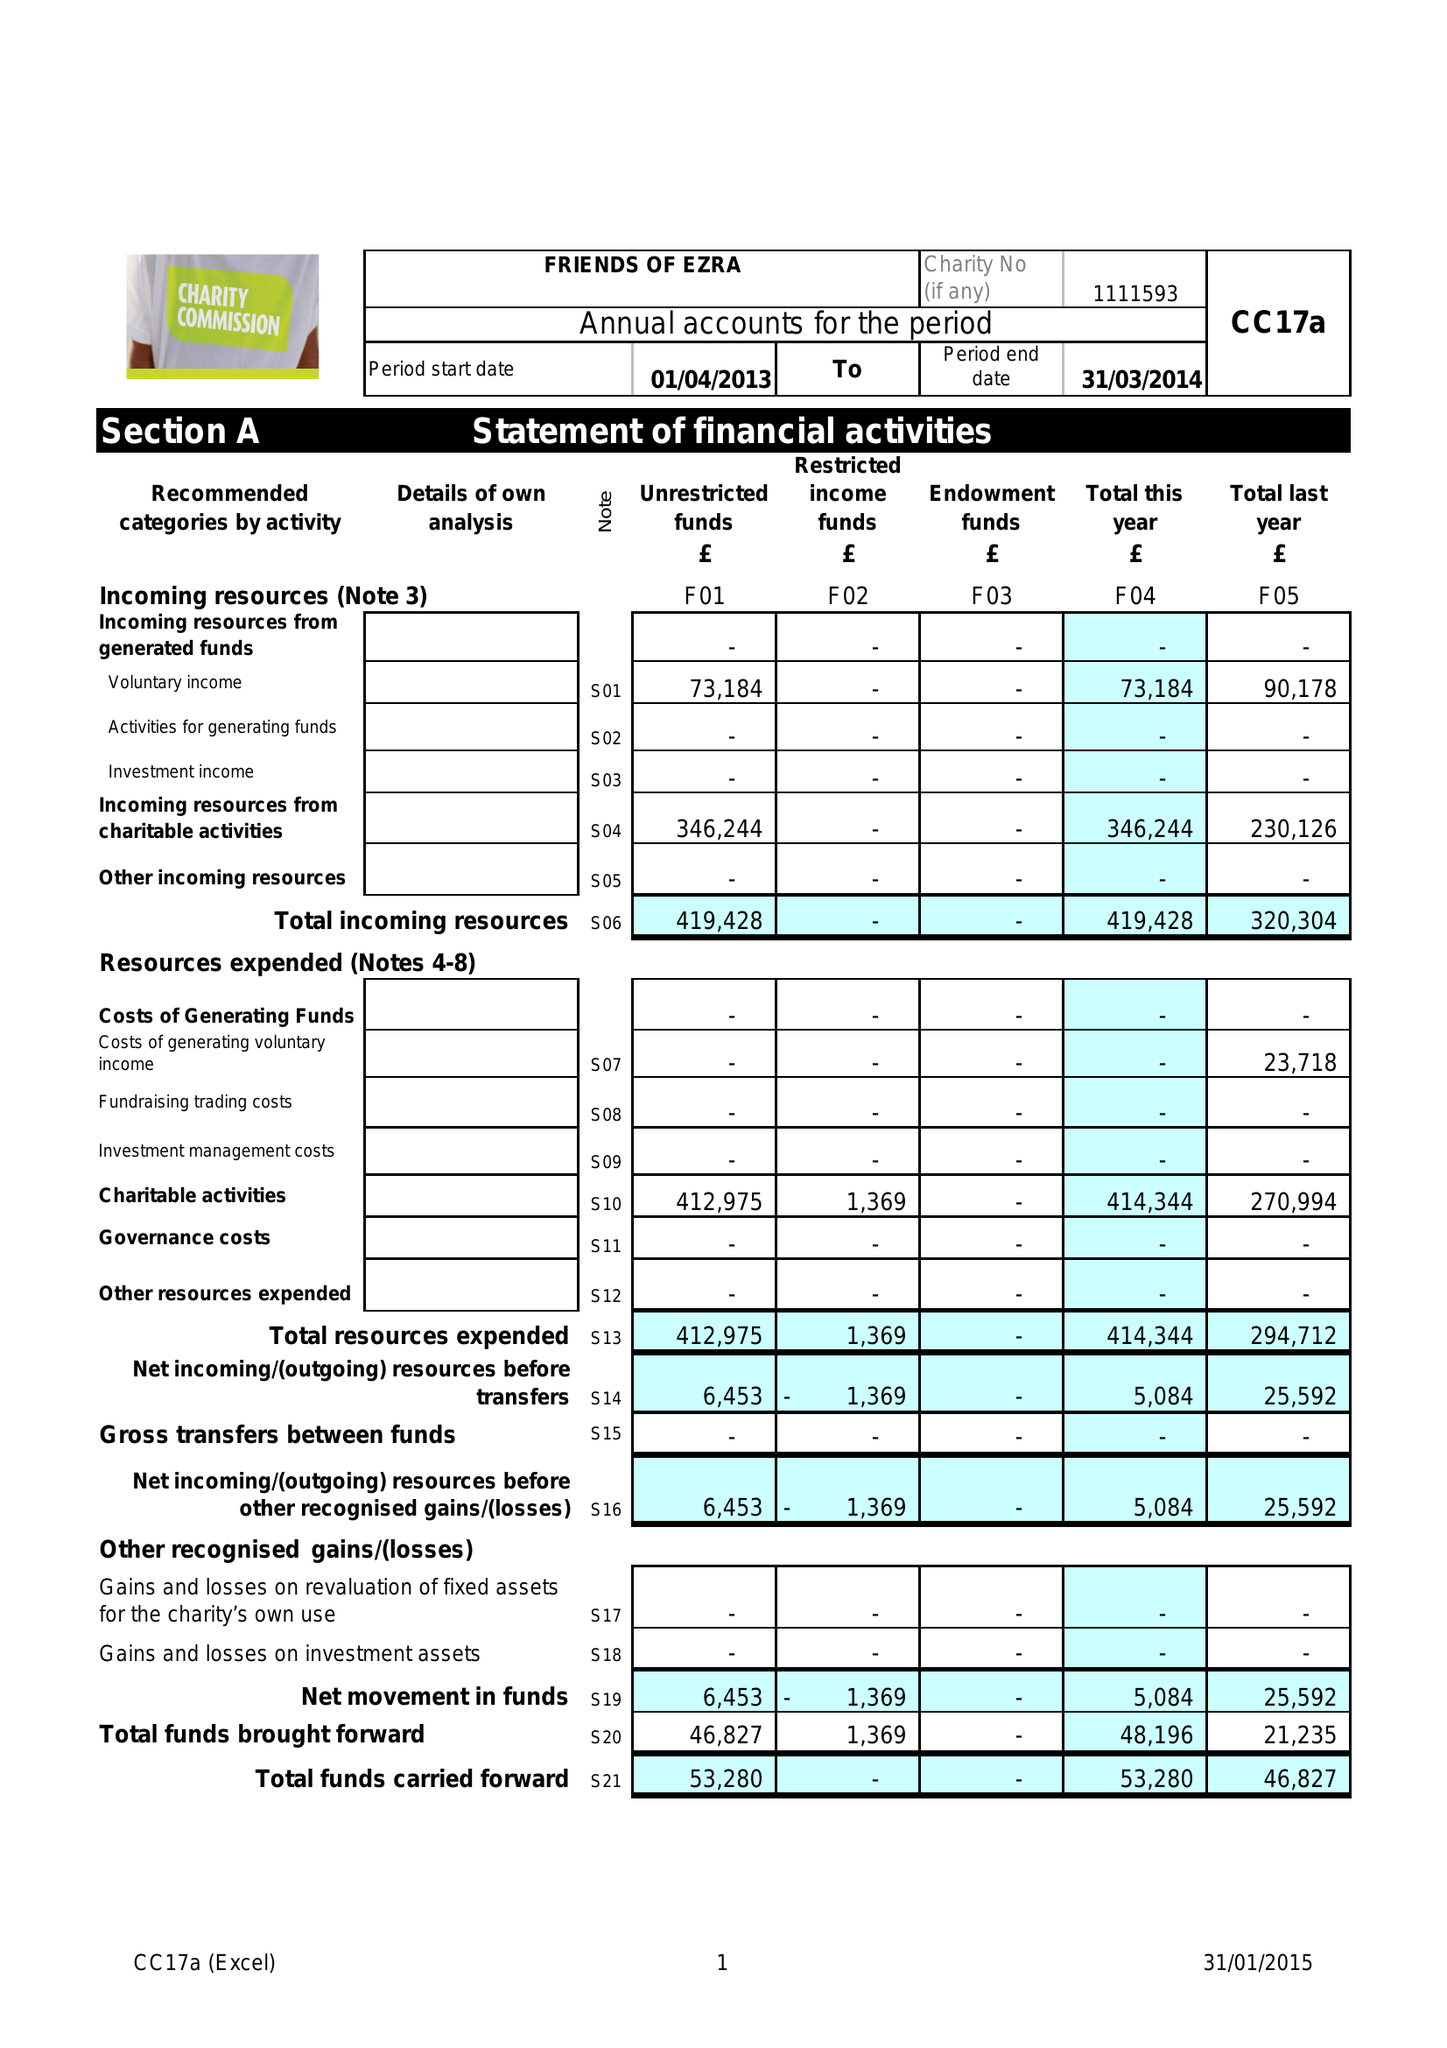What is the value for the address__street_line?
Answer the question using a single word or phrase. 35 GOLDERS GARDENS 